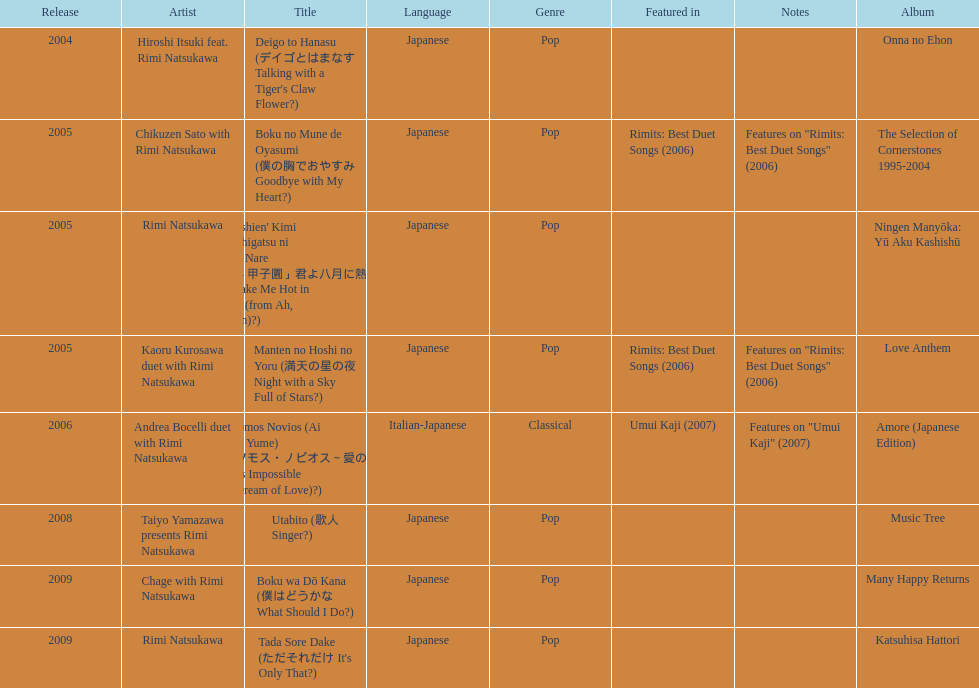What year was onna no ehon released? 2004. What year was music tree released? 2008. Which of the two was not released in 2004? Music Tree. 